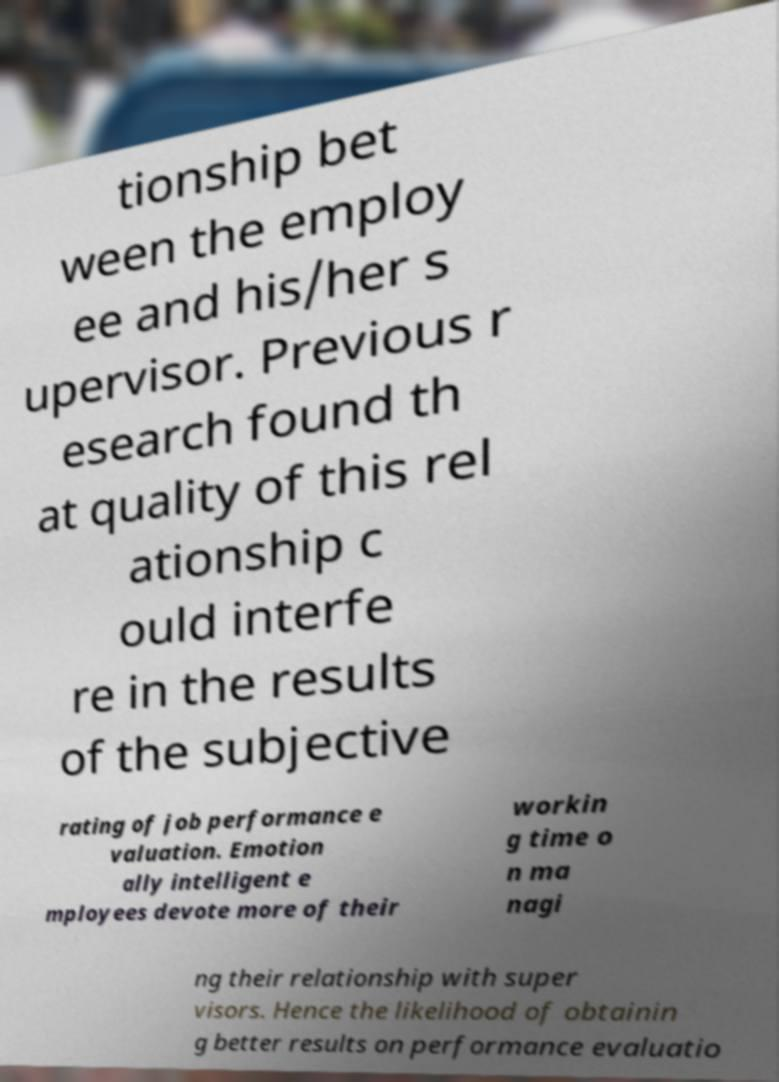Could you assist in decoding the text presented in this image and type it out clearly? tionship bet ween the employ ee and his/her s upervisor. Previous r esearch found th at quality of this rel ationship c ould interfe re in the results of the subjective rating of job performance e valuation. Emotion ally intelligent e mployees devote more of their workin g time o n ma nagi ng their relationship with super visors. Hence the likelihood of obtainin g better results on performance evaluatio 